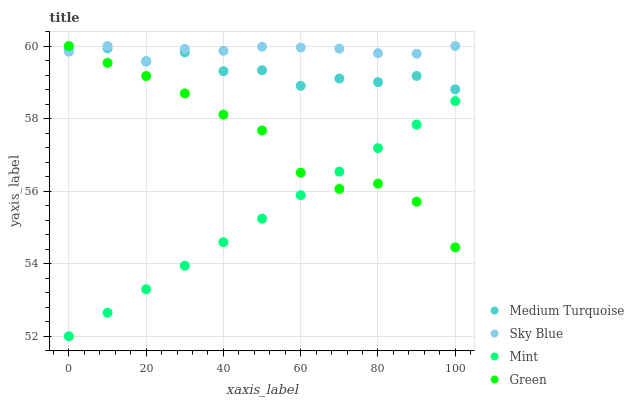Does Mint have the minimum area under the curve?
Answer yes or no. Yes. Does Sky Blue have the maximum area under the curve?
Answer yes or no. Yes. Does Green have the minimum area under the curve?
Answer yes or no. No. Does Green have the maximum area under the curve?
Answer yes or no. No. Is Mint the smoothest?
Answer yes or no. Yes. Is Medium Turquoise the roughest?
Answer yes or no. Yes. Is Green the smoothest?
Answer yes or no. No. Is Green the roughest?
Answer yes or no. No. Does Mint have the lowest value?
Answer yes or no. Yes. Does Green have the lowest value?
Answer yes or no. No. Does Green have the highest value?
Answer yes or no. Yes. Does Mint have the highest value?
Answer yes or no. No. Is Mint less than Sky Blue?
Answer yes or no. Yes. Is Sky Blue greater than Mint?
Answer yes or no. Yes. Does Green intersect Mint?
Answer yes or no. Yes. Is Green less than Mint?
Answer yes or no. No. Is Green greater than Mint?
Answer yes or no. No. Does Mint intersect Sky Blue?
Answer yes or no. No. 